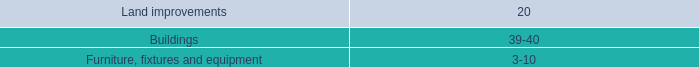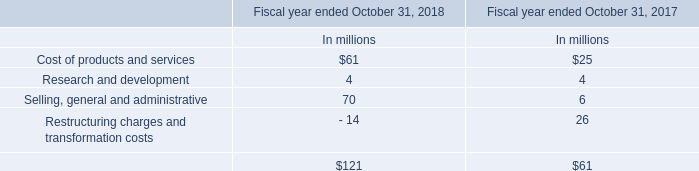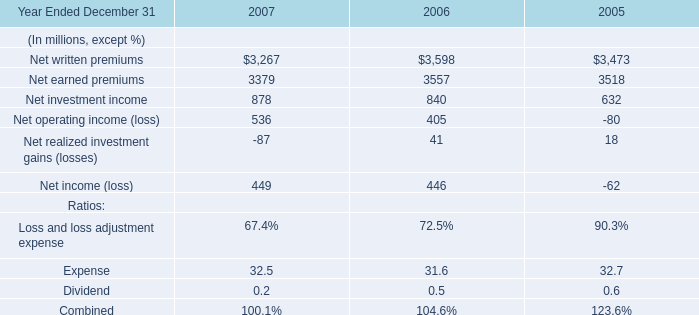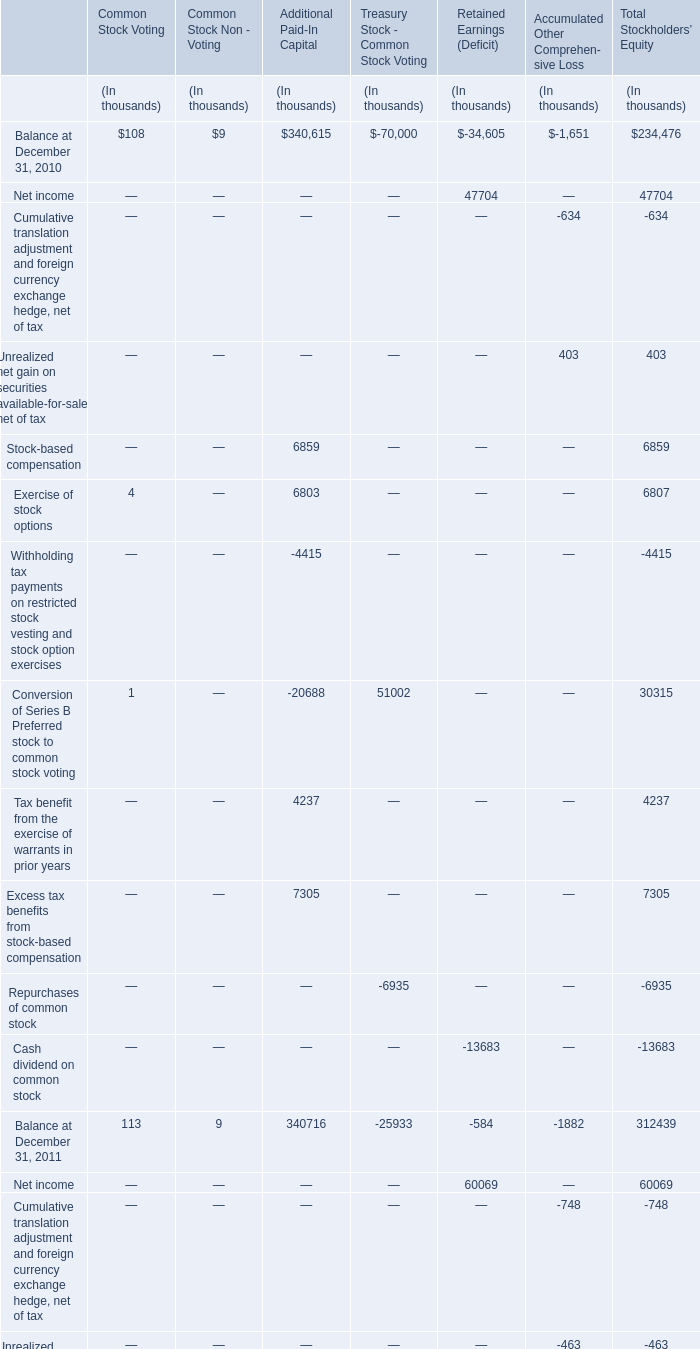what the difference of the held-to-maturity securities at cost and at fair value as of january 30 , 2009 , in millions? 
Computations: (31.4 - 28.9)
Answer: 2.5. 